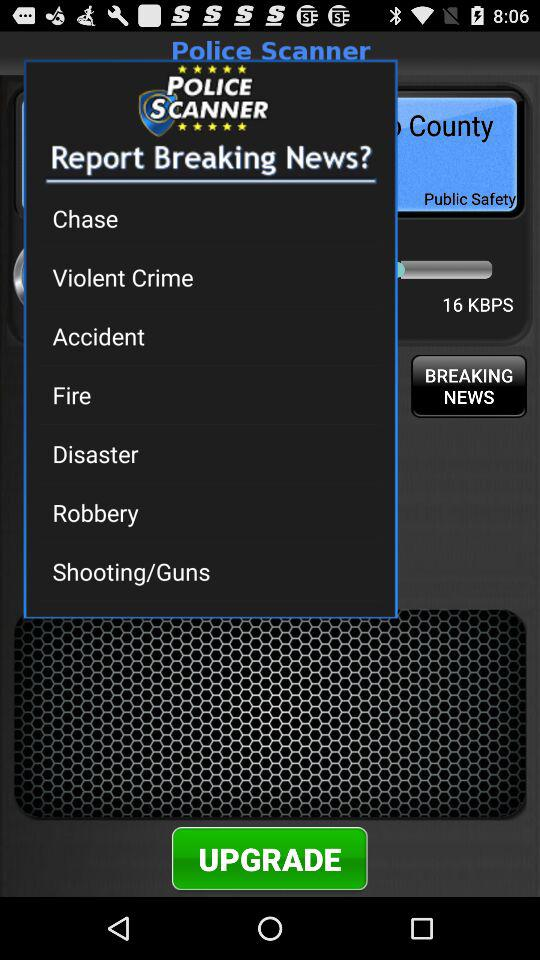What is the name of the application? The name of the application is "Police Scanner". 